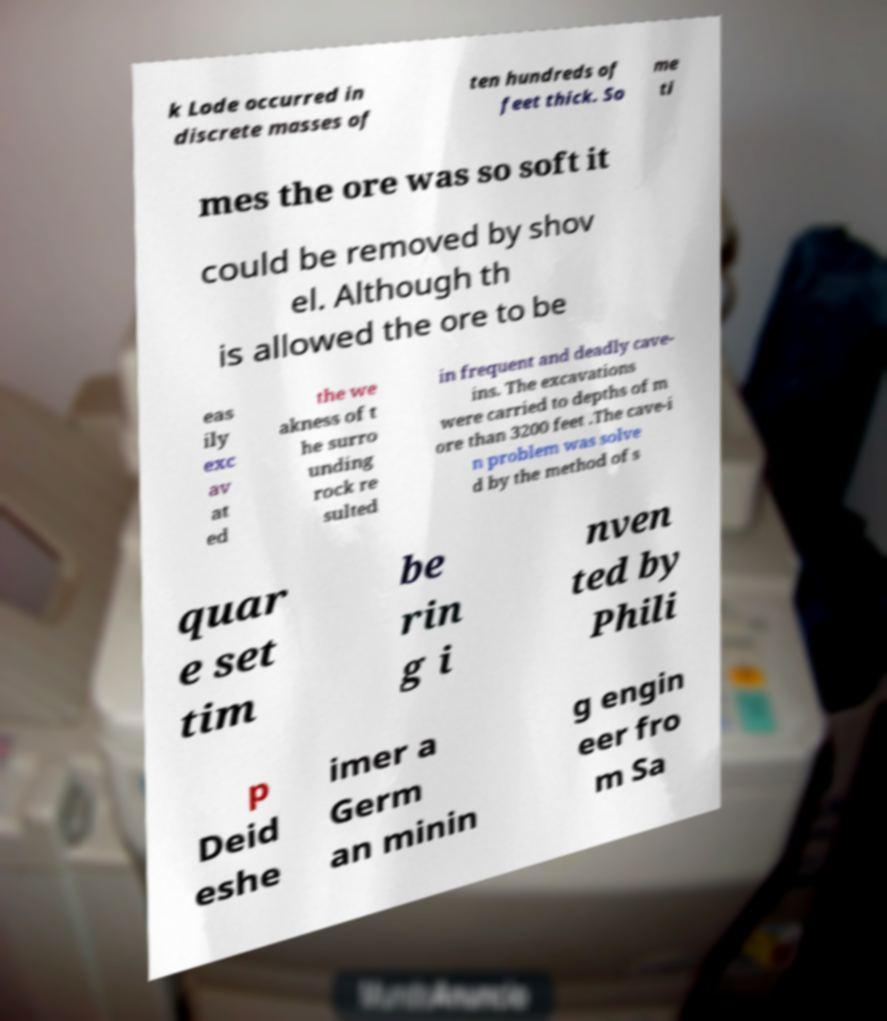Could you extract and type out the text from this image? k Lode occurred in discrete masses of ten hundreds of feet thick. So me ti mes the ore was so soft it could be removed by shov el. Although th is allowed the ore to be eas ily exc av at ed the we akness of t he surro unding rock re sulted in frequent and deadly cave- ins. The excavations were carried to depths of m ore than 3200 feet .The cave-i n problem was solve d by the method of s quar e set tim be rin g i nven ted by Phili p Deid eshe imer a Germ an minin g engin eer fro m Sa 